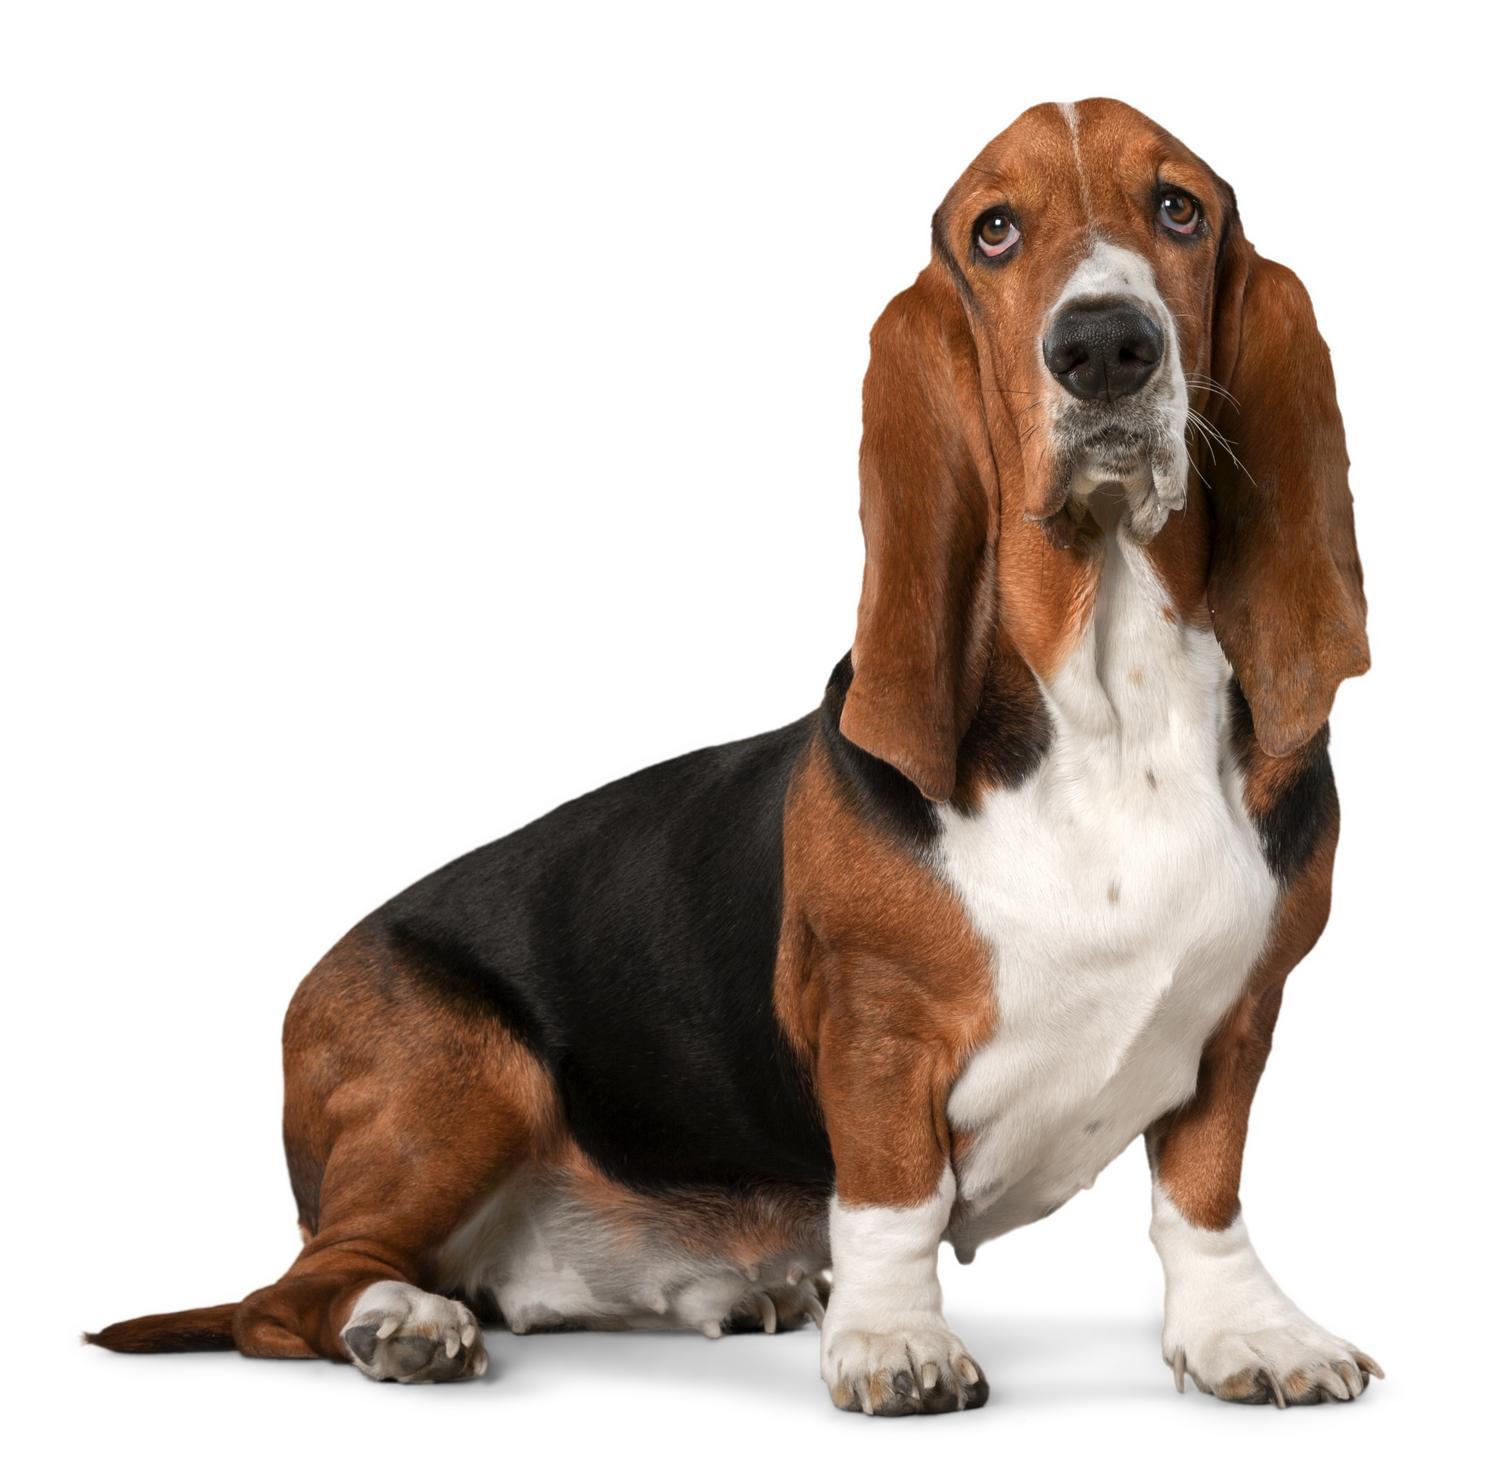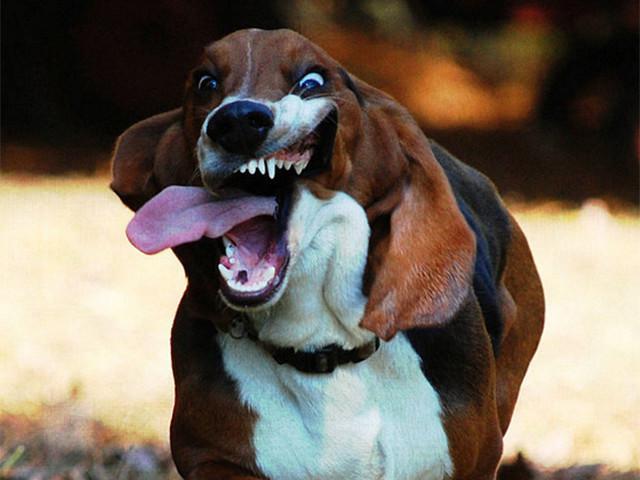The first image is the image on the left, the second image is the image on the right. For the images shown, is this caption "At least one dog has no visible black in their fur." true? Answer yes or no. No. 